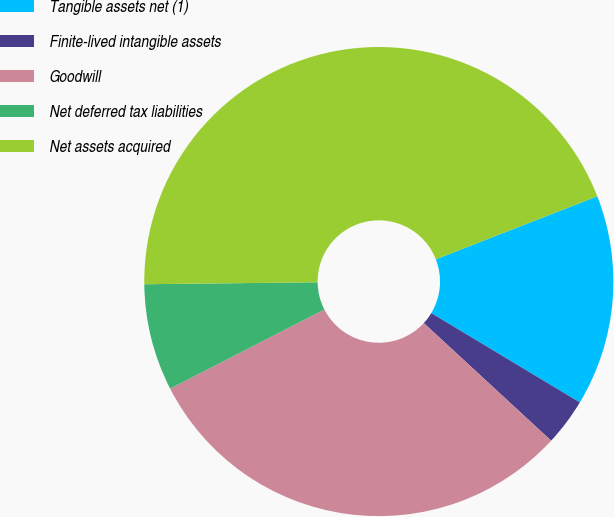Convert chart to OTSL. <chart><loc_0><loc_0><loc_500><loc_500><pie_chart><fcel>Tangible assets net (1)<fcel>Finite-lived intangible assets<fcel>Goodwill<fcel>Net deferred tax liabilities<fcel>Net assets acquired<nl><fcel>14.54%<fcel>3.25%<fcel>30.59%<fcel>7.36%<fcel>44.26%<nl></chart> 